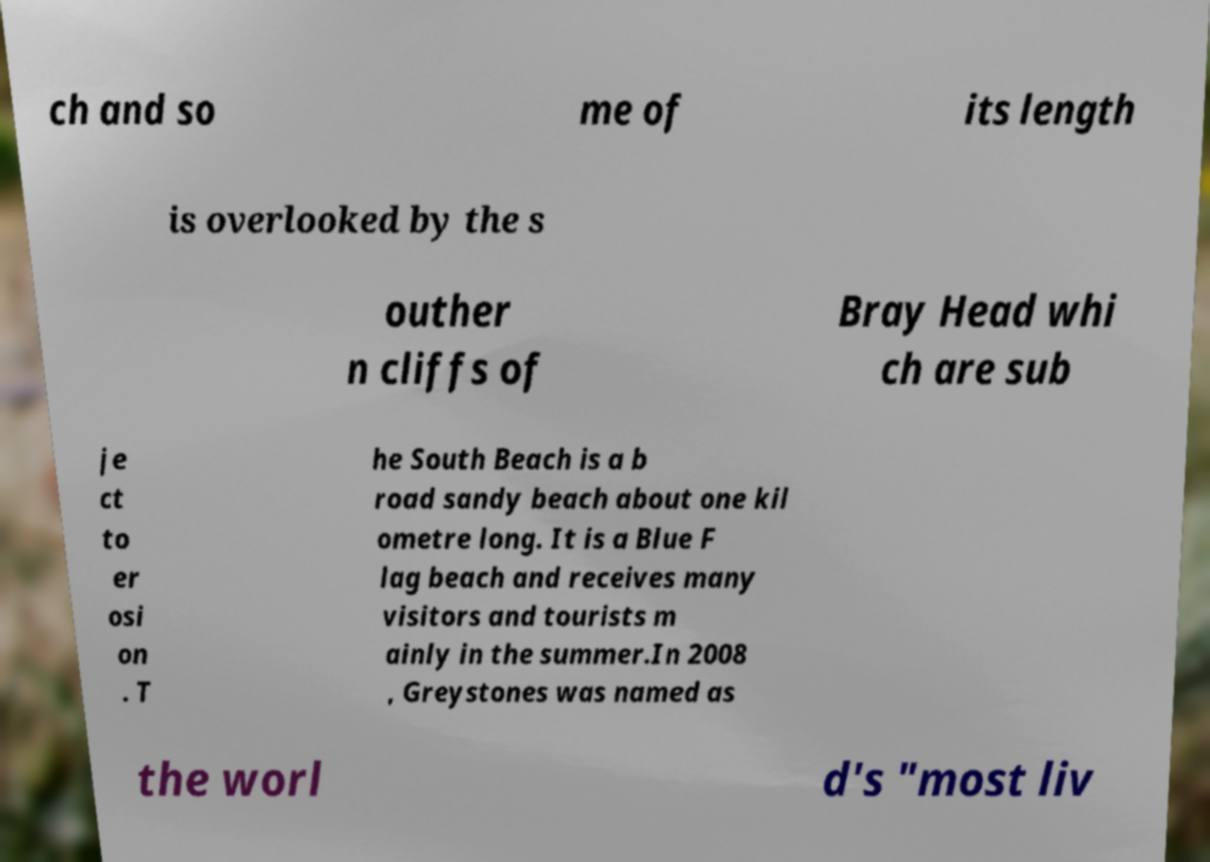Please read and relay the text visible in this image. What does it say? ch and so me of its length is overlooked by the s outher n cliffs of Bray Head whi ch are sub je ct to er osi on . T he South Beach is a b road sandy beach about one kil ometre long. It is a Blue F lag beach and receives many visitors and tourists m ainly in the summer.In 2008 , Greystones was named as the worl d's "most liv 